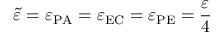<formula> <loc_0><loc_0><loc_500><loc_500>\tilde { \varepsilon } = \varepsilon _ { P A } = \varepsilon _ { E C } = \varepsilon _ { P E } = \frac { \varepsilon } { 4 }</formula> 